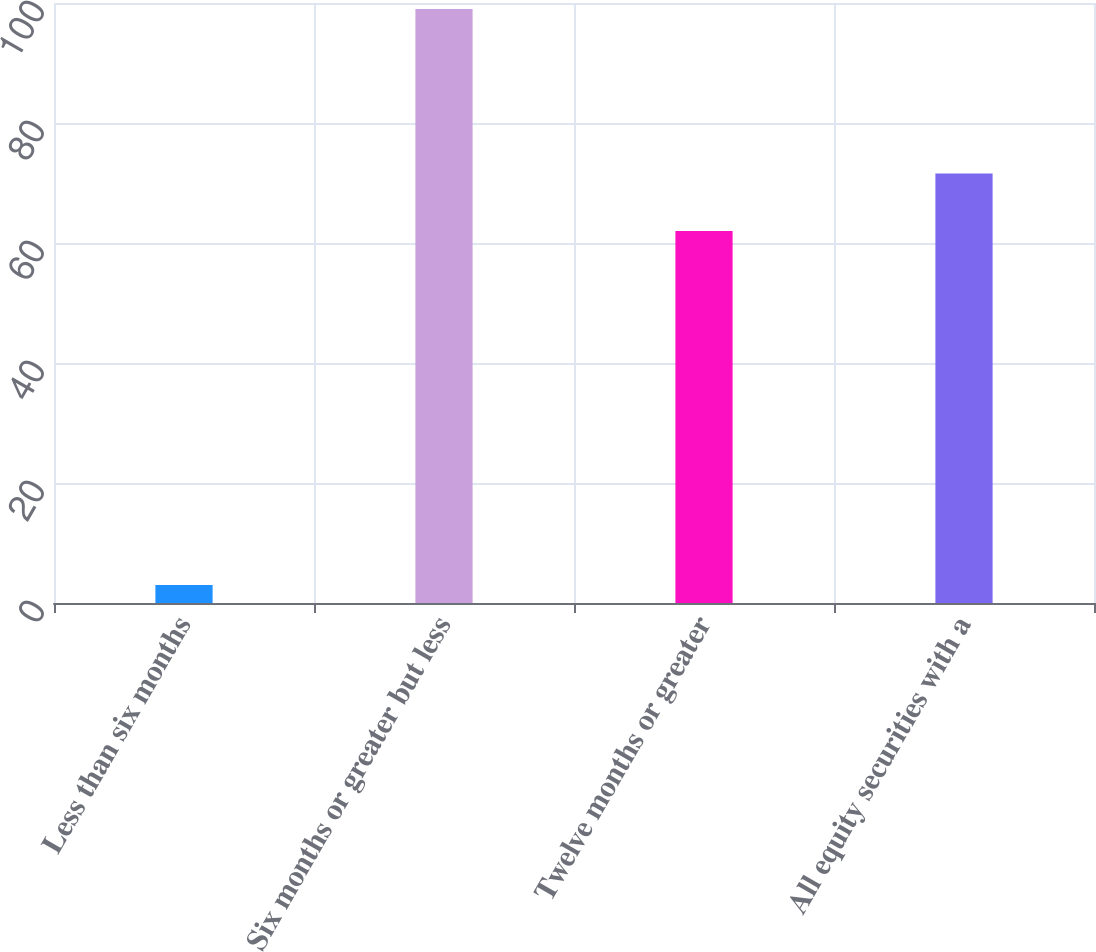Convert chart. <chart><loc_0><loc_0><loc_500><loc_500><bar_chart><fcel>Less than six months<fcel>Six months or greater but less<fcel>Twelve months or greater<fcel>All equity securities with a<nl><fcel>3<fcel>99<fcel>62<fcel>71.6<nl></chart> 